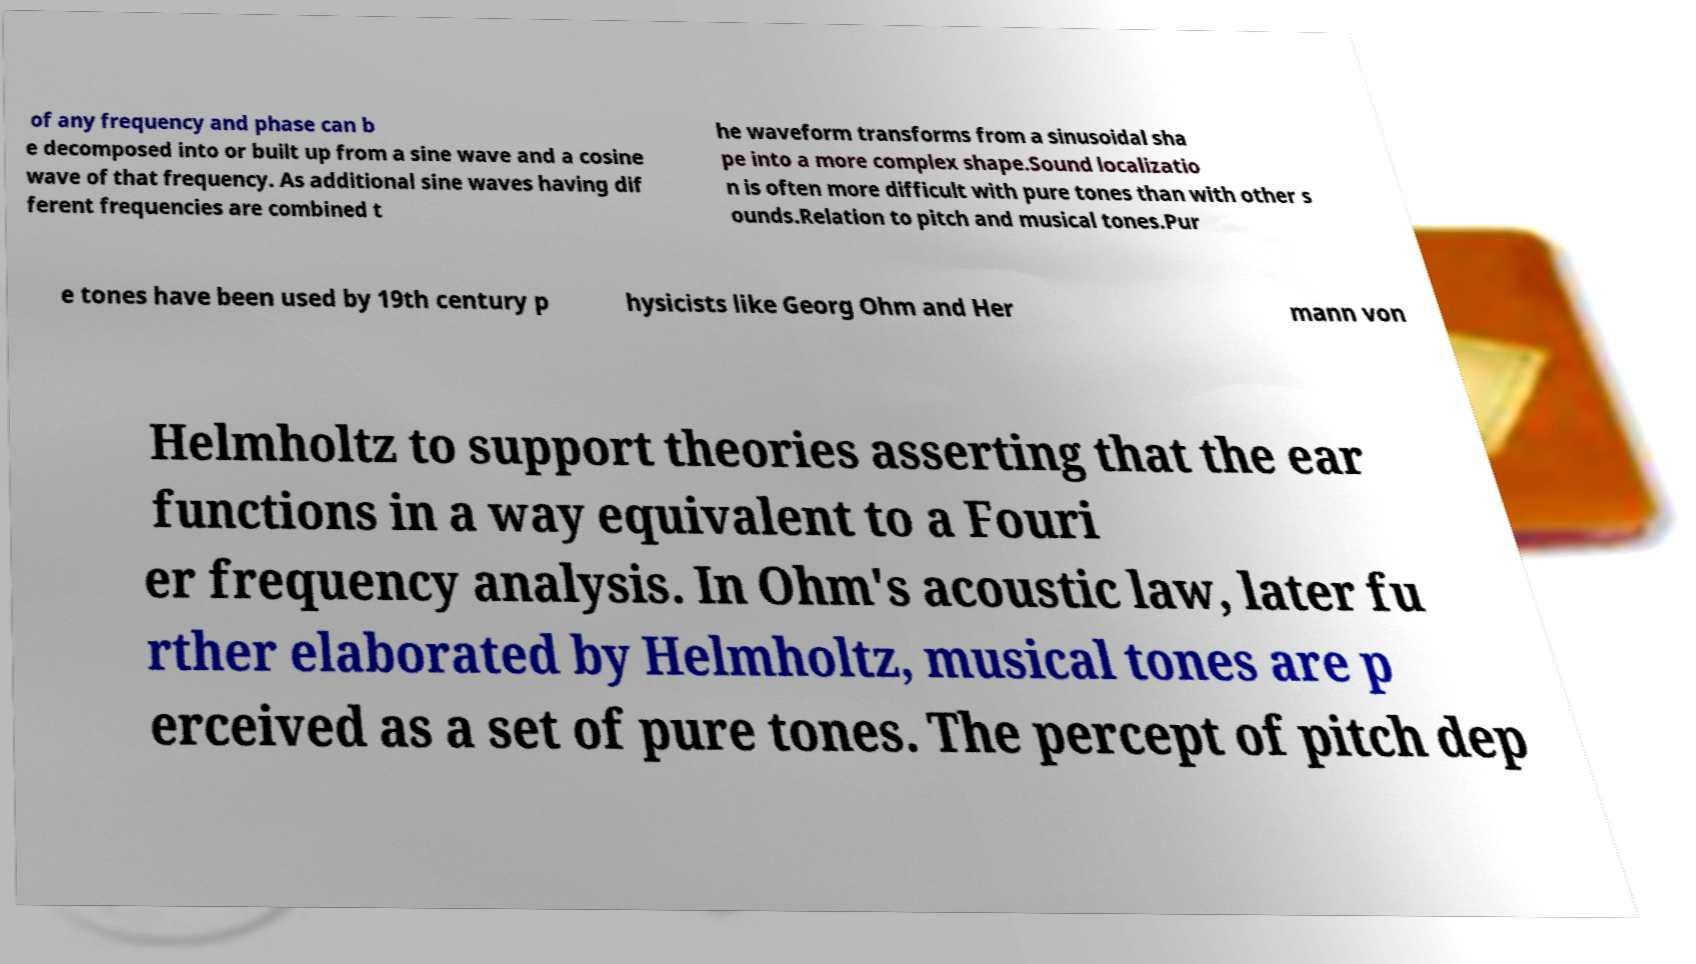There's text embedded in this image that I need extracted. Can you transcribe it verbatim? of any frequency and phase can b e decomposed into or built up from a sine wave and a cosine wave of that frequency. As additional sine waves having dif ferent frequencies are combined t he waveform transforms from a sinusoidal sha pe into a more complex shape.Sound localizatio n is often more difficult with pure tones than with other s ounds.Relation to pitch and musical tones.Pur e tones have been used by 19th century p hysicists like Georg Ohm and Her mann von Helmholtz to support theories asserting that the ear functions in a way equivalent to a Fouri er frequency analysis. In Ohm's acoustic law, later fu rther elaborated by Helmholtz, musical tones are p erceived as a set of pure tones. The percept of pitch dep 